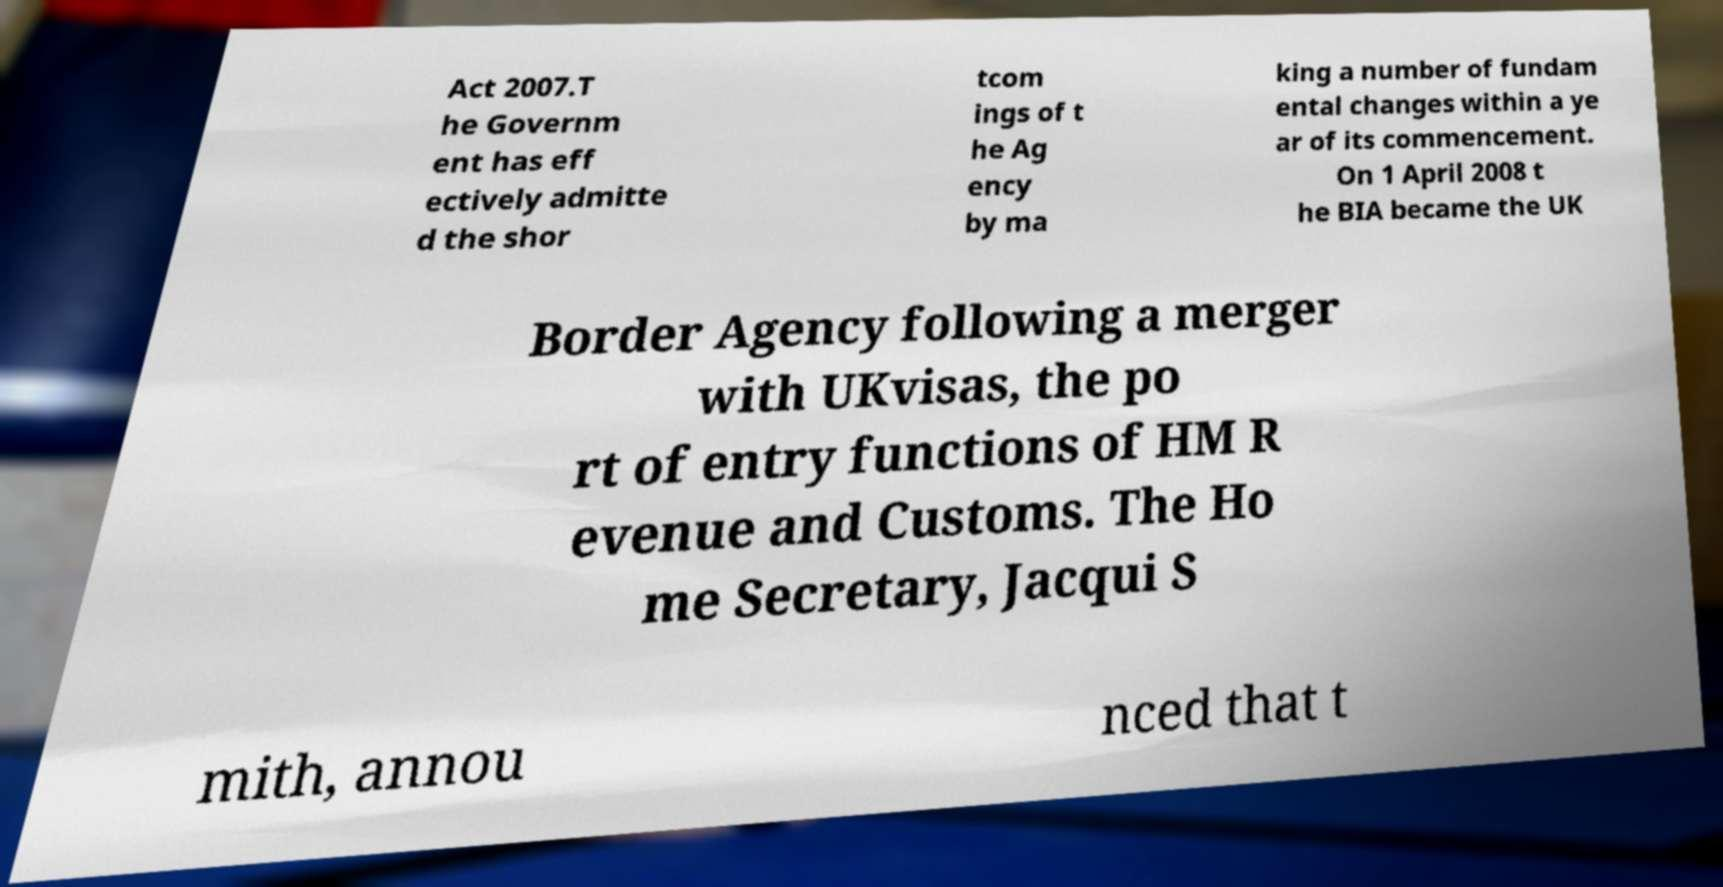Could you extract and type out the text from this image? Act 2007.T he Governm ent has eff ectively admitte d the shor tcom ings of t he Ag ency by ma king a number of fundam ental changes within a ye ar of its commencement. On 1 April 2008 t he BIA became the UK Border Agency following a merger with UKvisas, the po rt of entry functions of HM R evenue and Customs. The Ho me Secretary, Jacqui S mith, annou nced that t 